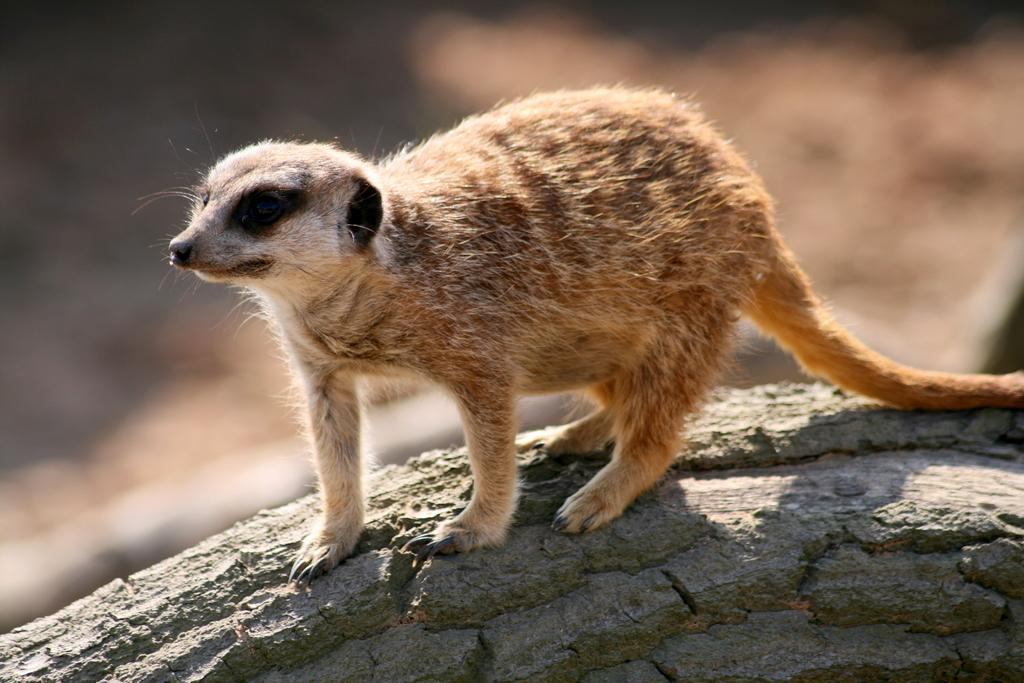What animal is the main subject of the image? There is a mongoose in the image. What is the mongoose standing on? The mongoose is standing on a rock. Can you describe the background of the image? The background of the image appears blurry. How many toes does the mongoose have on its front paw in the image? The image does not provide enough detail to count the number of toes on the mongoose's paw. 